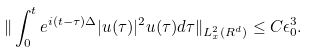Convert formula to latex. <formula><loc_0><loc_0><loc_500><loc_500>\| \int _ { 0 } ^ { t } e ^ { i ( t - \tau ) \Delta } | u ( \tau ) | ^ { 2 } u ( \tau ) d \tau \| _ { L _ { x } ^ { 2 } ( R ^ { d } ) } \leq C \epsilon _ { 0 } ^ { 3 } .</formula> 